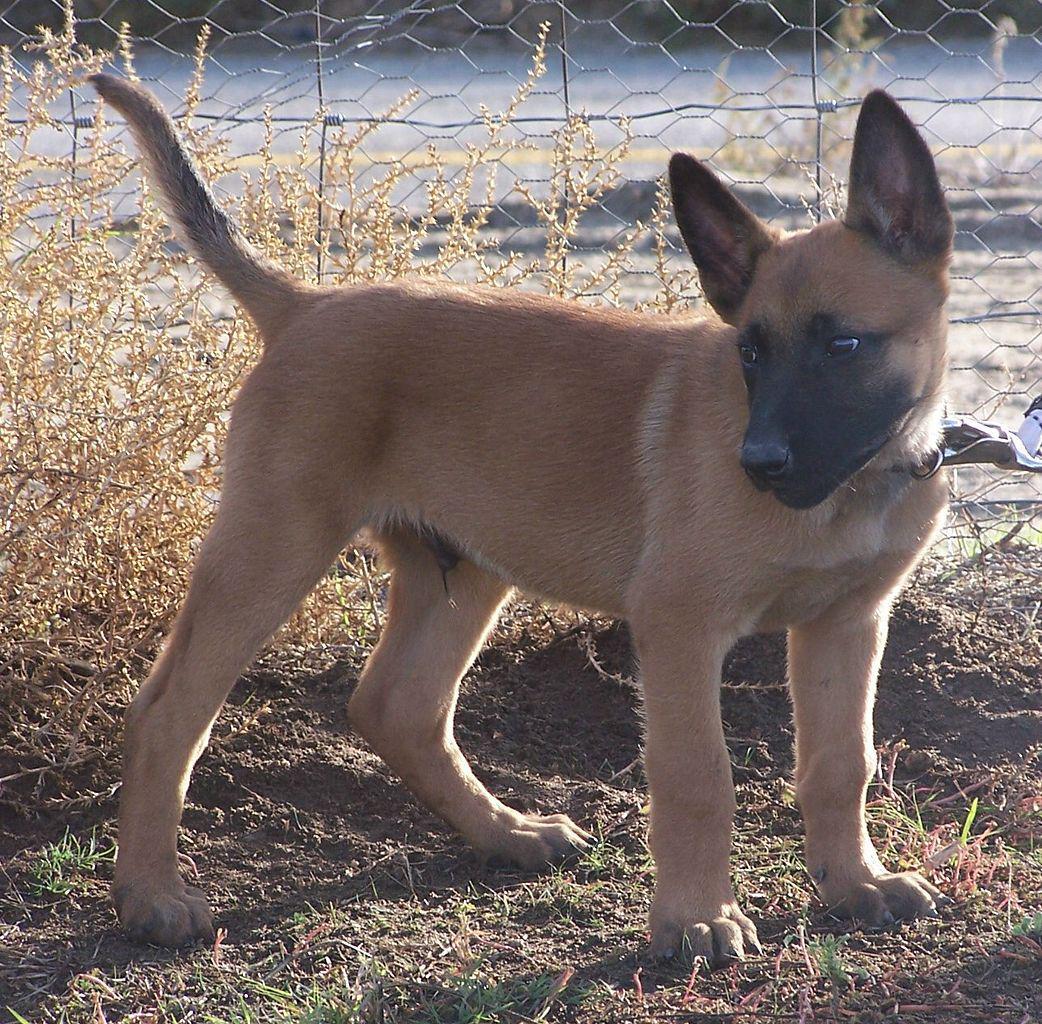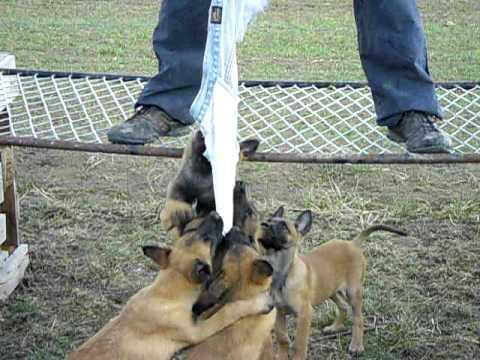The first image is the image on the left, the second image is the image on the right. For the images displayed, is the sentence "The left image contains two dogs." factually correct? Answer yes or no. No. The first image is the image on the left, the second image is the image on the right. Given the left and right images, does the statement "The righthand image contains exactly one dog, which is sitting upright with its body turned to the camera." hold true? Answer yes or no. No. 